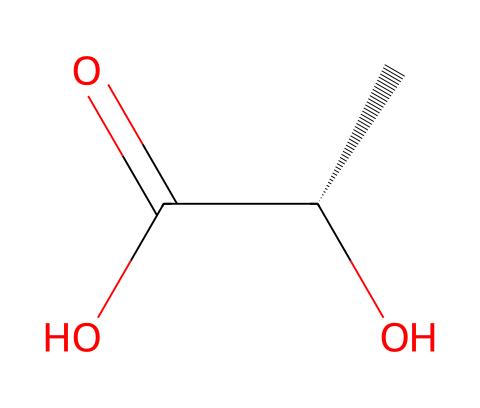What is the molecular formula of this compound? To determine the molecular formula, we count the number of carbon (C), hydrogen (H), and oxygen (O) atoms in the structure. There are two carbon atoms, four hydrogen atoms, and two oxygen atoms, which gives us the formula C2H4O2.
Answer: C2H4O2 How many stereocenters are present in D-lactic acid? The structure includes a carbon atom bonded to four different groups (the chiral center at the second carbon). Hence, there is one stereocenter in D-lactic acid.
Answer: one What type of isomerism does D-lactic acid exhibit? Since D-lactic acid has a stereocenter, it can exist as two enantiomers (D and L forms), demonstrating optical isomerism.
Answer: optical isomerism What functional groups are present in this molecule? By examining the structure, we can identify that D-lactic acid contains a carboxylic acid group (C(=O)O) and a hydroxyl group (O).
Answer: carboxylic acid and hydroxyl What is the stereochemical designation of this compound? The chiral center configuration indicates that this specific compound is the D enantiomer, based on the Cahn-Ingold-Prelog priority rules for the groups attached.
Answer: D What is the total number of hydrogen atoms in the molecule? Counting the hydrogen atoms in the structure, there are four hydrogen atoms bonded to the carbon and hydroxyl groups, giving us a total of four hydrogen atoms in D-lactic acid.
Answer: four How does the presence of chirality affect the biological activity of D-lactic acid? Chirality can result in distinct biological properties and interactions; in this case, the D form is known to be metabolized by specific bacteria, whereas the L form may not be.
Answer: different biological properties 